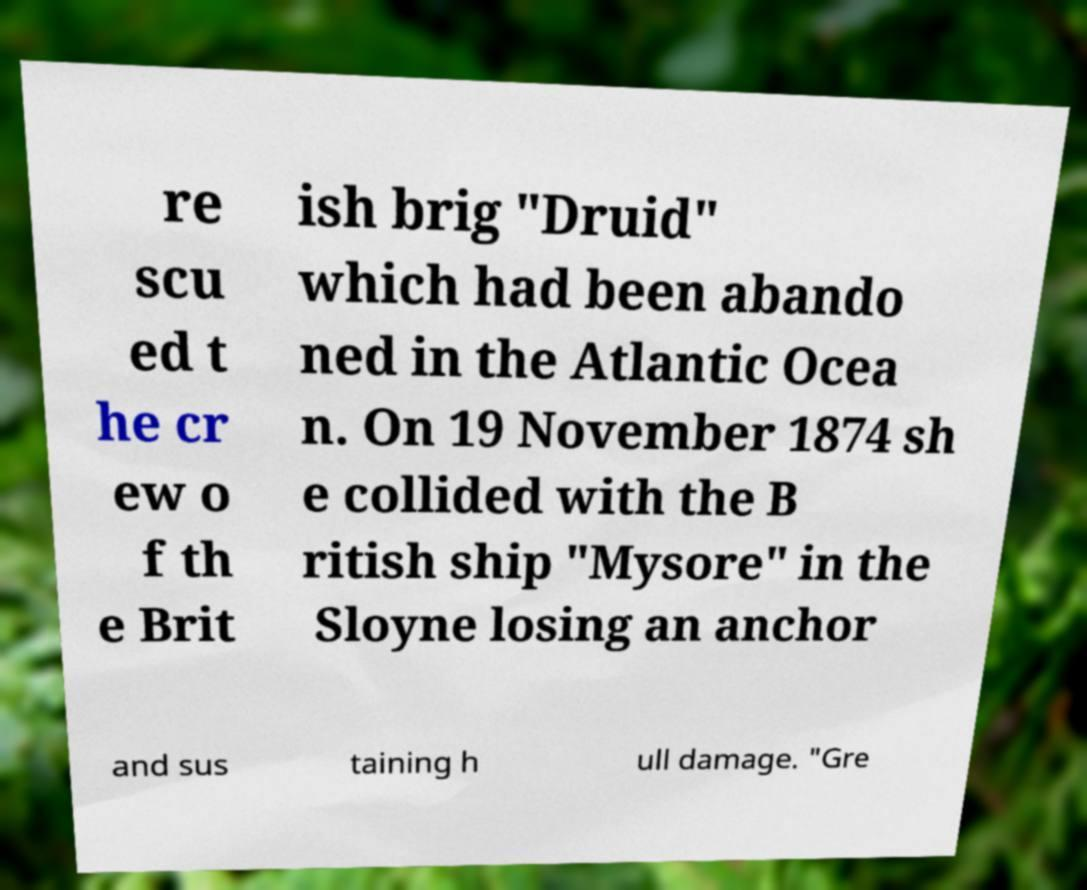Can you accurately transcribe the text from the provided image for me? re scu ed t he cr ew o f th e Brit ish brig "Druid" which had been abando ned in the Atlantic Ocea n. On 19 November 1874 sh e collided with the B ritish ship "Mysore" in the Sloyne losing an anchor and sus taining h ull damage. "Gre 